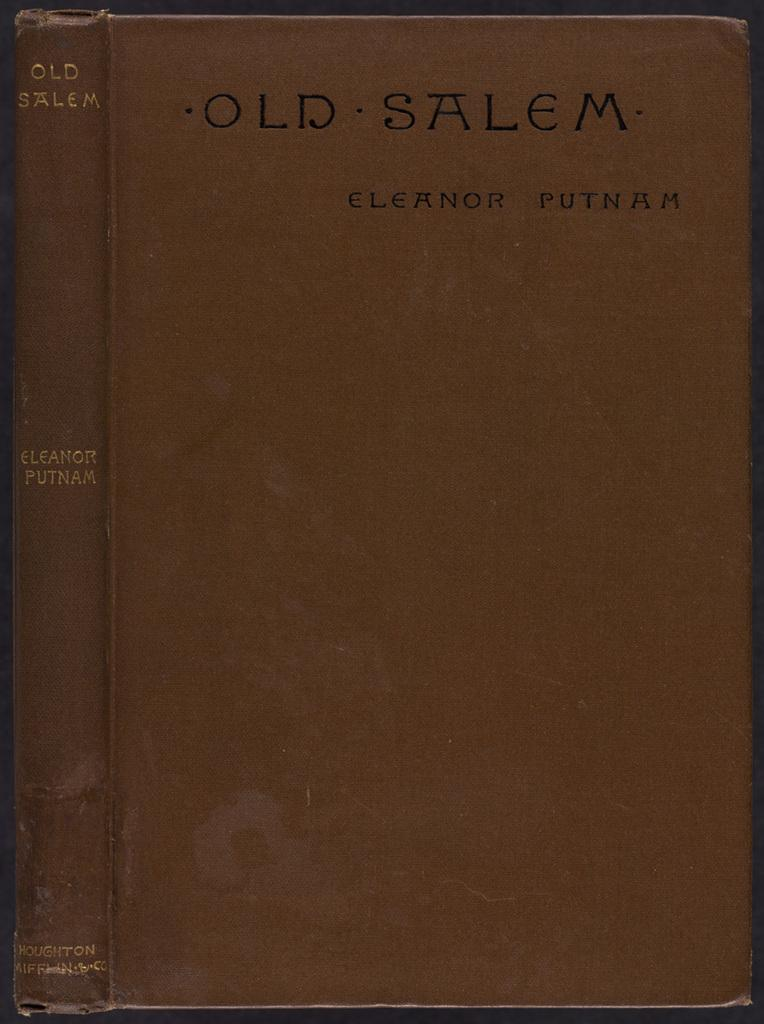What type of object is in the image? There is a brown book in the image. What is written on the book? The book has the title "Old Salem" written on it. How many hands are holding the book in the image? There are no hands visible in the image, as it only shows a brown book with the title "Old Salem" written on it. 